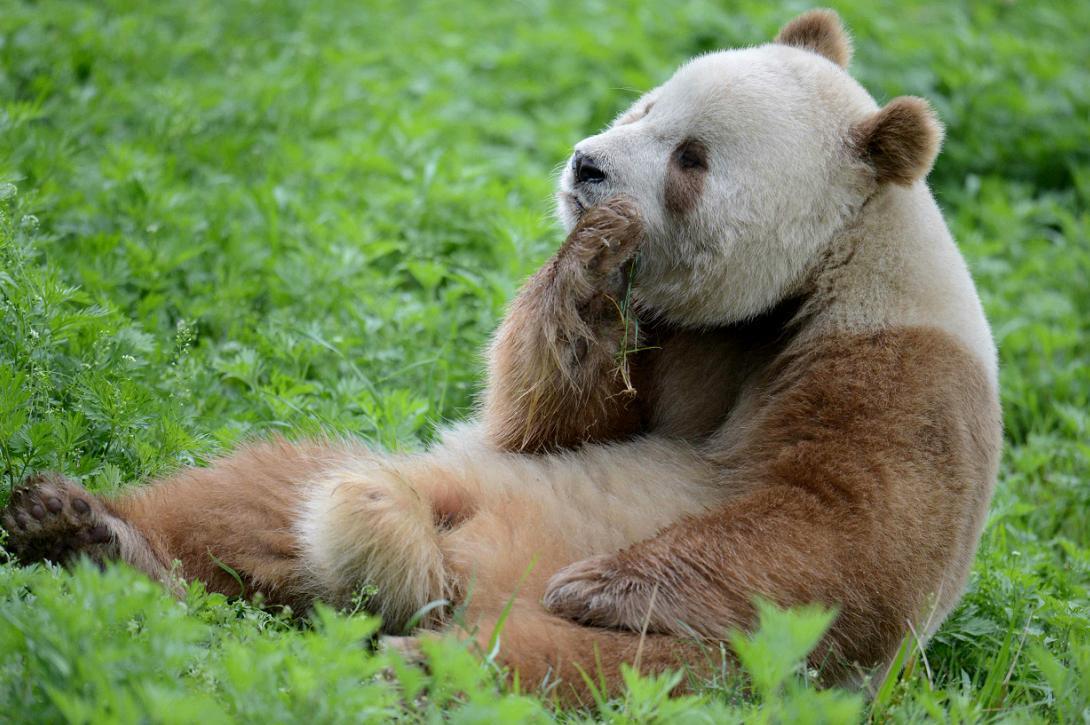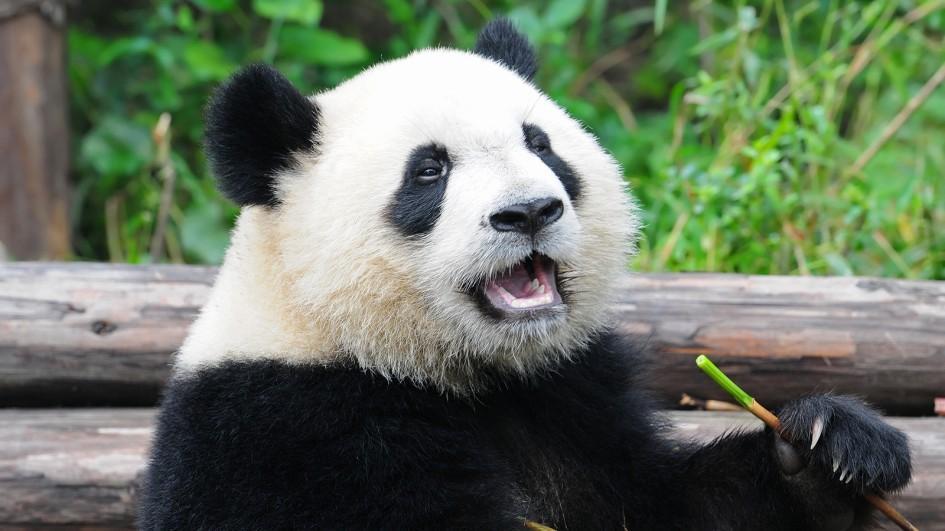The first image is the image on the left, the second image is the image on the right. For the images shown, is this caption "In both image the panda is eating." true? Answer yes or no. Yes. The first image is the image on the left, the second image is the image on the right. For the images shown, is this caption "There is a Panda sitting and eating bamboo." true? Answer yes or no. Yes. 